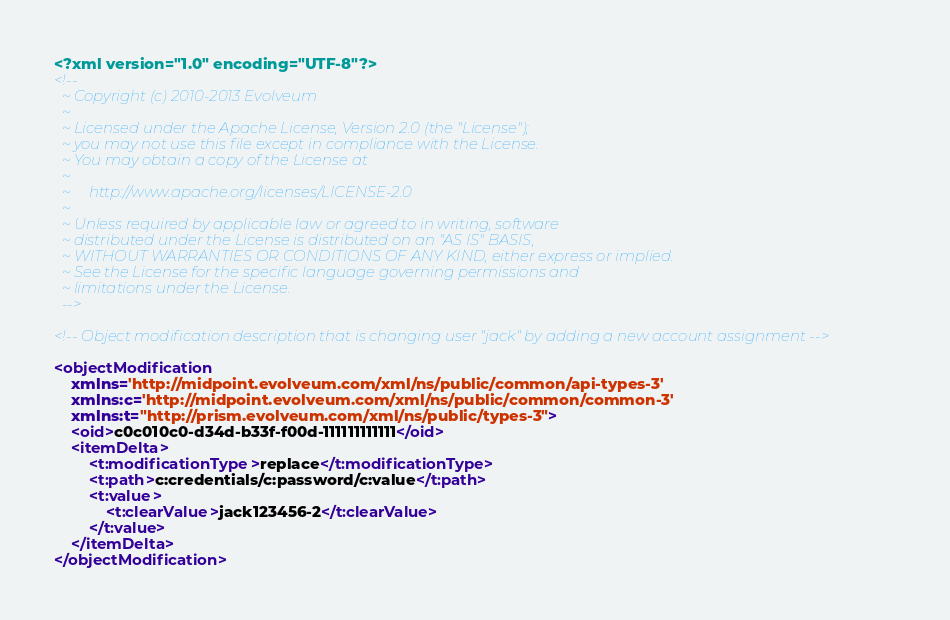<code> <loc_0><loc_0><loc_500><loc_500><_XML_><?xml version="1.0" encoding="UTF-8"?>
<!--
  ~ Copyright (c) 2010-2013 Evolveum
  ~
  ~ Licensed under the Apache License, Version 2.0 (the "License");
  ~ you may not use this file except in compliance with the License.
  ~ You may obtain a copy of the License at
  ~
  ~     http://www.apache.org/licenses/LICENSE-2.0
  ~
  ~ Unless required by applicable law or agreed to in writing, software
  ~ distributed under the License is distributed on an "AS IS" BASIS,
  ~ WITHOUT WARRANTIES OR CONDITIONS OF ANY KIND, either express or implied.
  ~ See the License for the specific language governing permissions and
  ~ limitations under the License.
  -->

<!-- Object modification description that is changing user "jack" by adding a new account assignment -->

<objectModification
	xmlns='http://midpoint.evolveum.com/xml/ns/public/common/api-types-3'
	xmlns:c='http://midpoint.evolveum.com/xml/ns/public/common/common-3'
	xmlns:t="http://prism.evolveum.com/xml/ns/public/types-3">
	<oid>c0c010c0-d34d-b33f-f00d-111111111111</oid>
	<itemDelta>
		<t:modificationType>replace</t:modificationType>
        <t:path>c:credentials/c:password/c:value</t:path>
        <t:value>
            <t:clearValue>jack123456-2</t:clearValue>
		</t:value>
	</itemDelta>
</objectModification>
</code> 